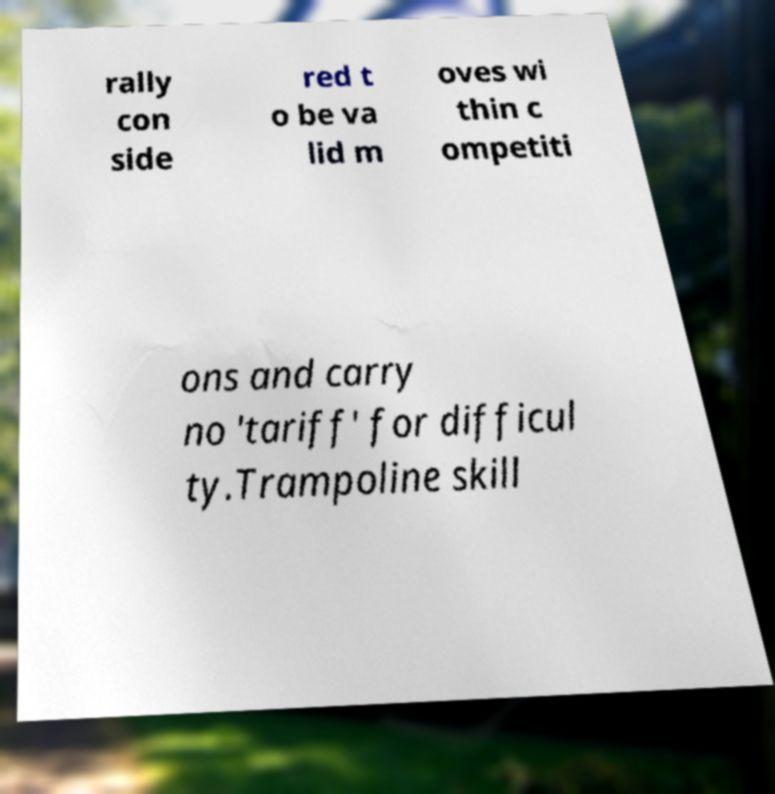For documentation purposes, I need the text within this image transcribed. Could you provide that? rally con side red t o be va lid m oves wi thin c ompetiti ons and carry no 'tariff' for difficul ty.Trampoline skill 